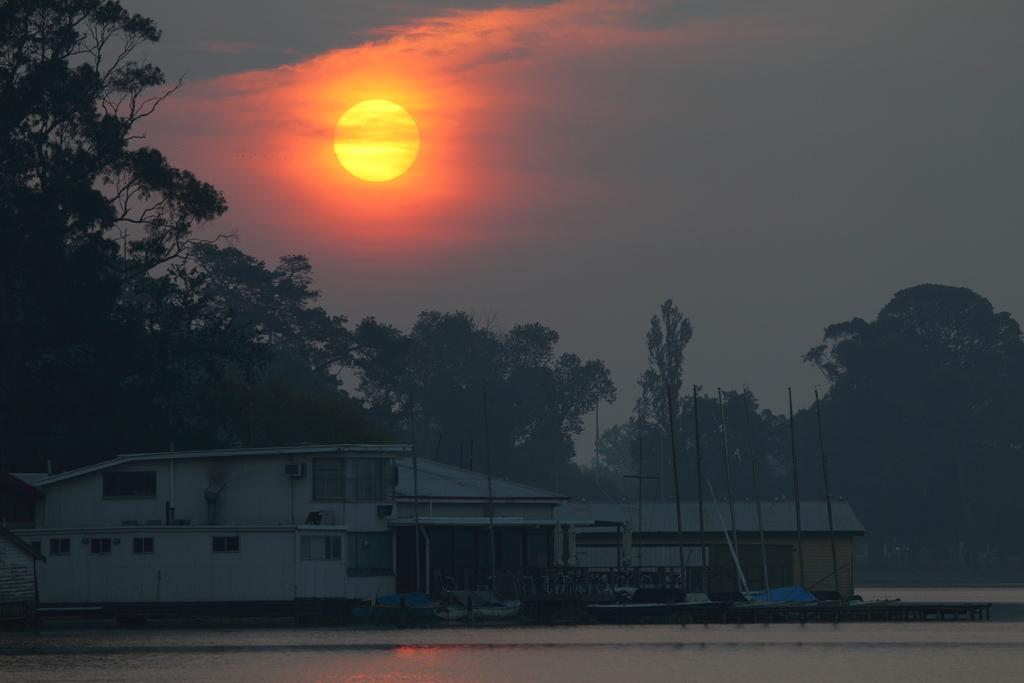What type of structures can be seen in the image? There are buildings in the image. What can be seen in the background of the image? There are trees in the background of the image. How is the sun depicted in the image? The sun is visible in the image, with colors described as yellow and orange. What colors are present in the sky in the image? The sky is visible in the image, with colors described as white and gray. Where is the desk located in the image? There is no desk present in the image. What type of jelly is being used to paint the trees in the image? There is no jelly or painting activity depicted in the image; it features buildings, trees, the sun, and the sky. 